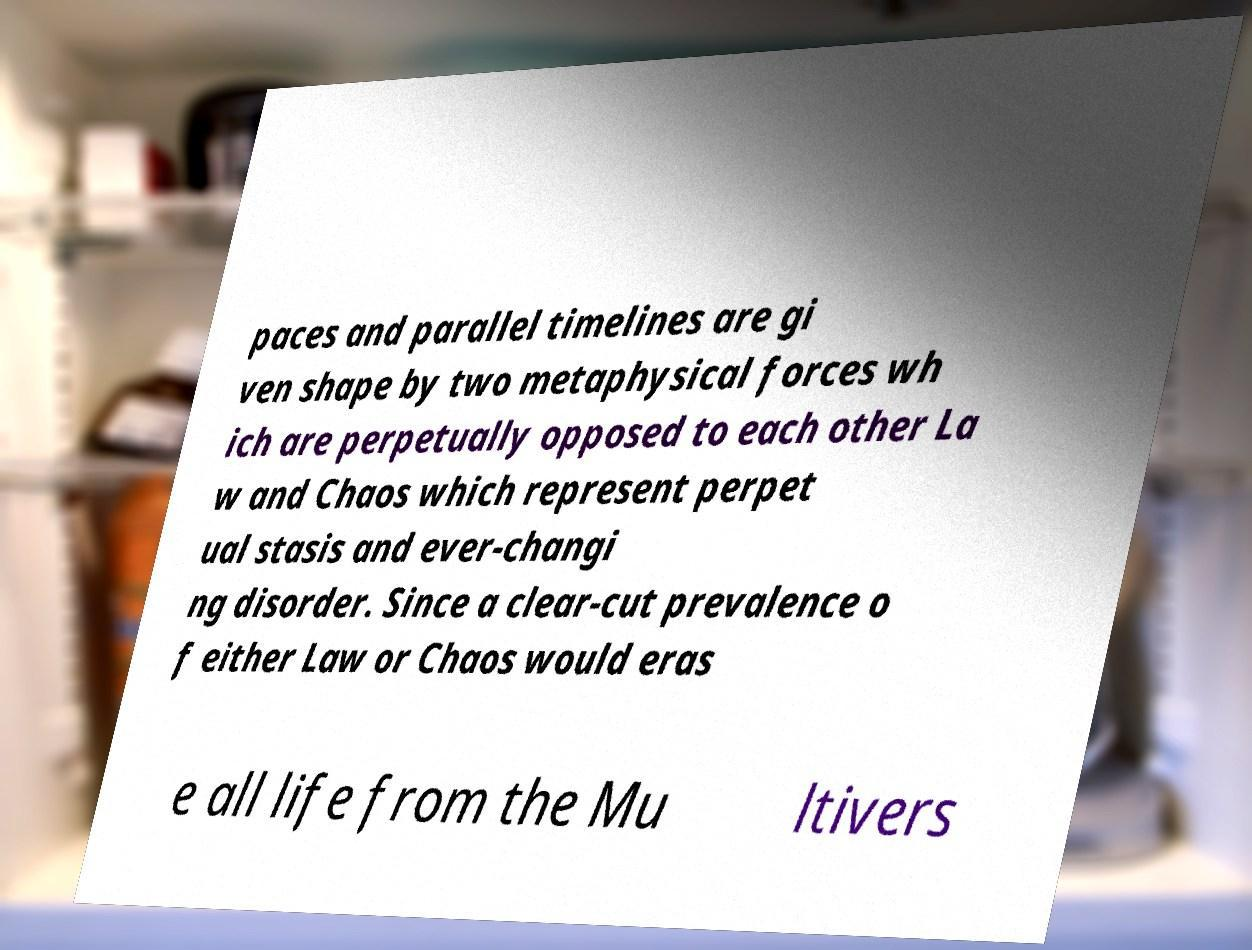Please read and relay the text visible in this image. What does it say? paces and parallel timelines are gi ven shape by two metaphysical forces wh ich are perpetually opposed to each other La w and Chaos which represent perpet ual stasis and ever-changi ng disorder. Since a clear-cut prevalence o f either Law or Chaos would eras e all life from the Mu ltivers 